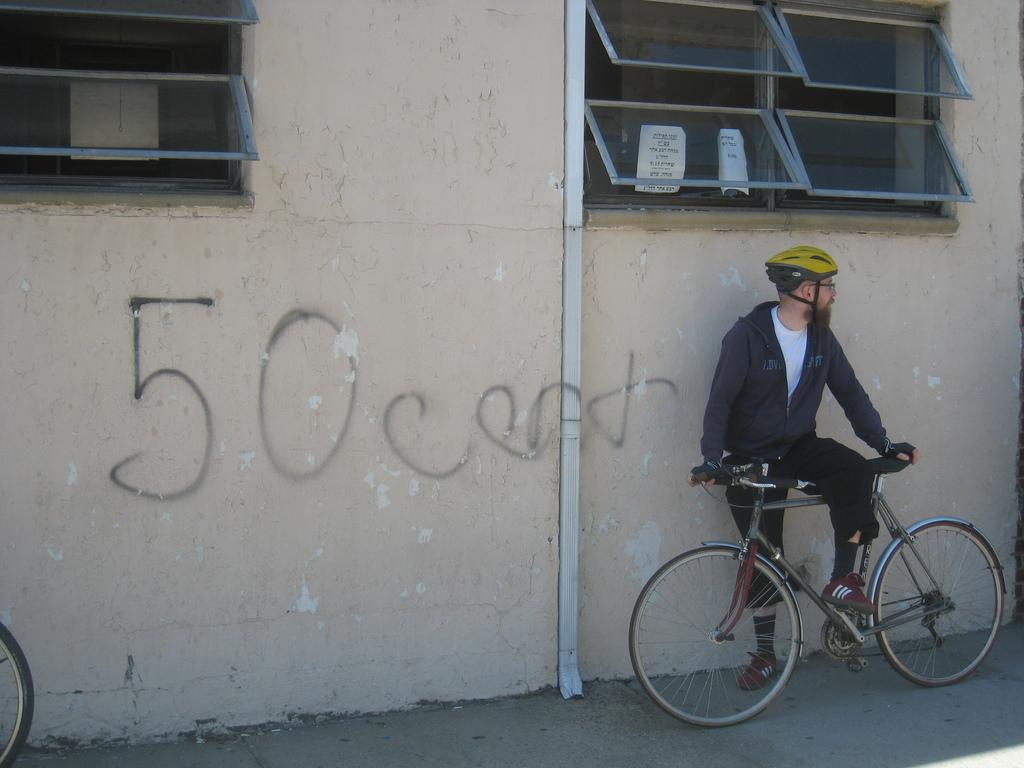Where is the person in the image located? The person is standing outside a house. What is the person holding in the image? The person is holding the handle of a bicycle. What safety gear is the person wearing? The person is wearing a helmet. What can be seen in the background of the image? There is a window and a wall visible in the background. What type of feather can be seen floating near the person in the image? There is no feather visible in the image. What type of work is the person doing in the image? The image does not show the person doing any work; they are simply standing outside a house with a bicycle. 